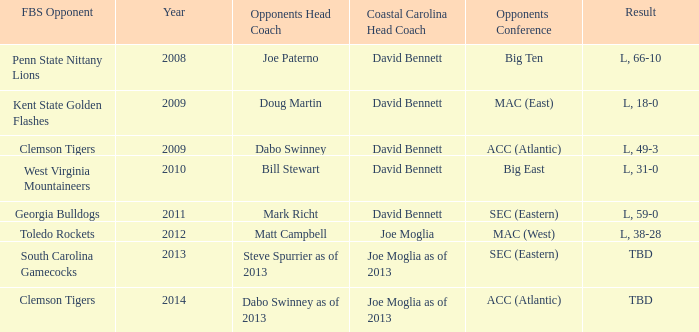What was the result when then opponents conference was Mac (east)? L, 18-0. 